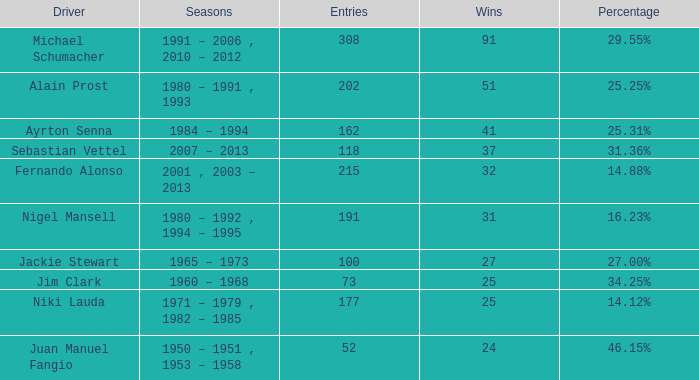Which driver has 162 participations? Ayrton Senna. 